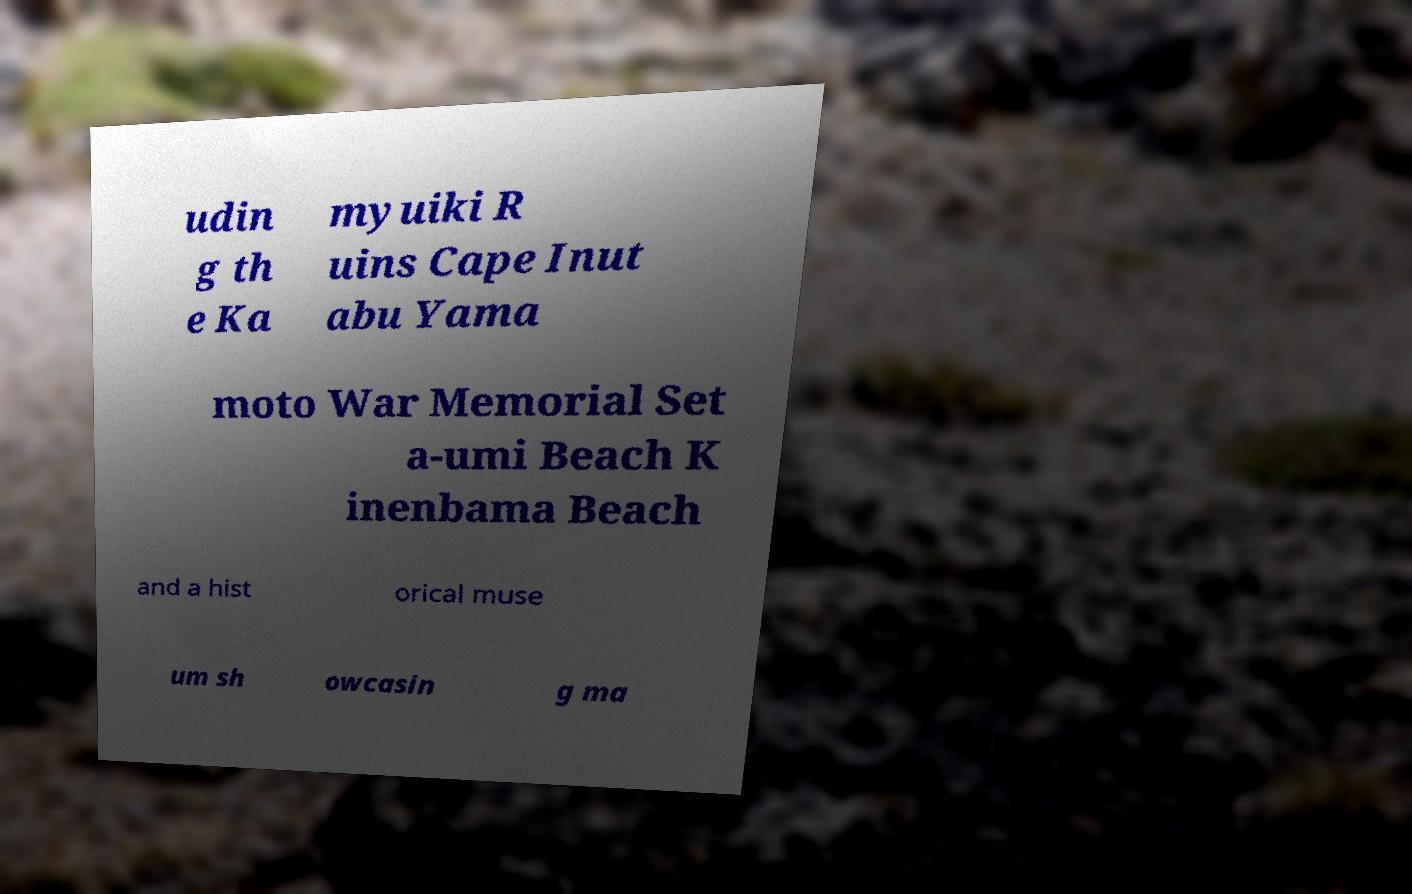Please read and relay the text visible in this image. What does it say? udin g th e Ka myuiki R uins Cape Inut abu Yama moto War Memorial Set a-umi Beach K inenbama Beach and a hist orical muse um sh owcasin g ma 